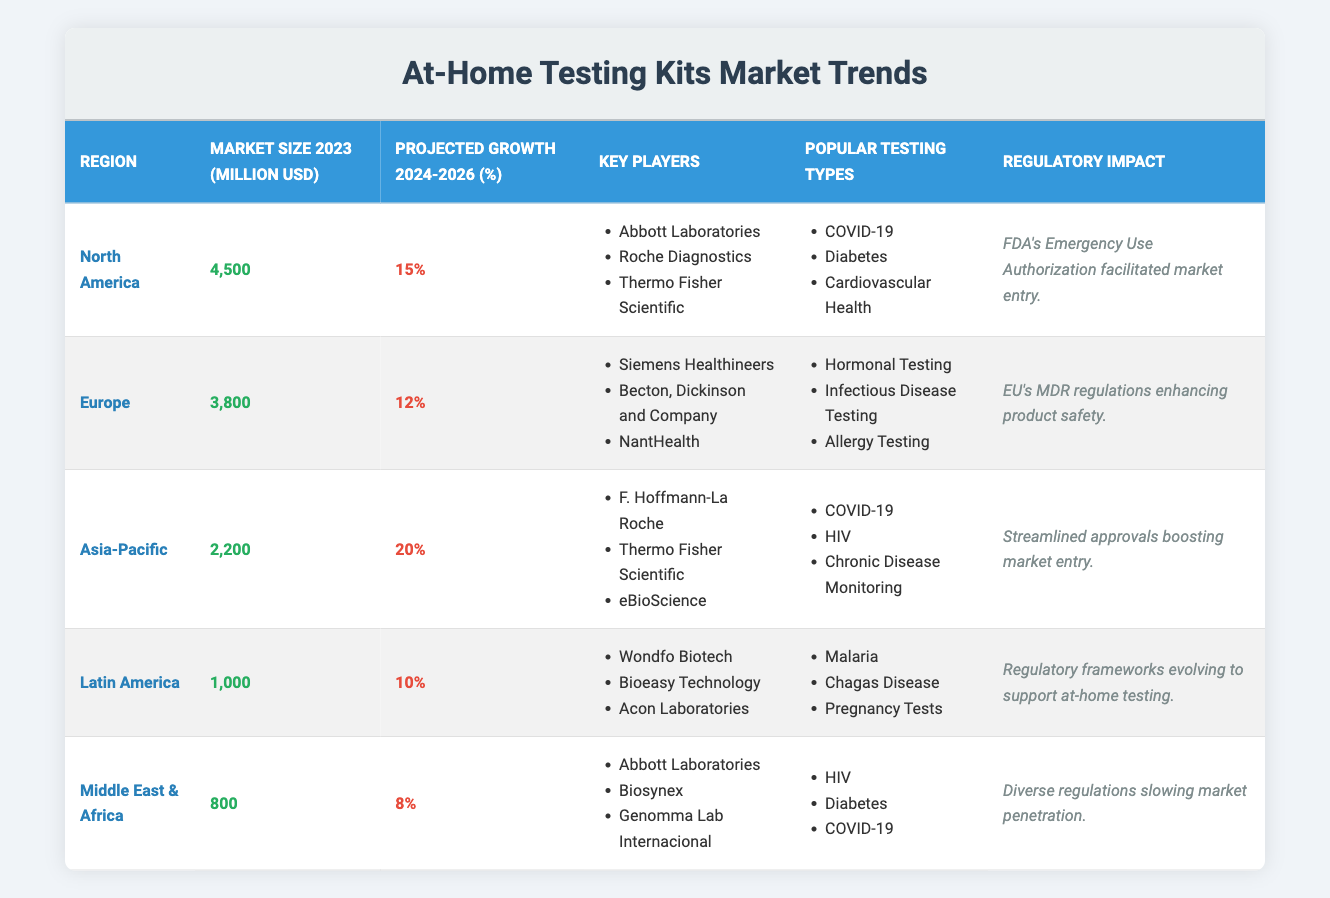What is the market size of at-home testing kits in Asia-Pacific in 2023? The table indicates that the market size for at-home testing kits in the Asia-Pacific region in 2023 is specified as 2,200 million USD.
Answer: 2,200 million USD Which region has the highest projected growth between 2024 and 2026? The projected growth rates for each region are listed as follows: North America (15%), Europe (12%), Asia-Pacific (20%), Latin America (10%), and Middle East & Africa (8%). The highest percentage is 20% for Asia-Pacific.
Answer: Asia-Pacific Are Roche Diagnostics one of the key players in the Latin America region? Checking the key players in Latin America, the list includes Wondfo Biotech, Bioeasy Technology, and Acon Laboratories, but not Roche Diagnostics. Therefore, the statement is false.
Answer: No What is the difference in market size between North America and Latin America in 2023? The market size for North America is 4,500 million USD, and for Latin America, it is 1,000 million USD. Subtracting these two values gives us 4,500 - 1,000 = 3,500 million USD as the difference.
Answer: 3,500 million USD Which region has the least projected growth and what is that percentage? Listing the projected growth percentages: North America (15%), Europe (12%), Asia-Pacific (20%), Latin America (10%), and Middle East & Africa (8%). The smallest value is 8% for the Middle East & Africa.
Answer: Middle East & Africa, 8% What are the popular testing types in Europe and how do they compare to those in North America? In Europe, the popular testing types are Hormonal Testing, Infectious Disease Testing, and Allergy Testing. In North America, they are COVID-19, Diabetes, and Cardiovascular Health. The comparison shows differing focuses based on regional health needs.
Answer: Different focuses How many million USD is the market size of the Middle East & Africa region compared to the Asia-Pacific region? The Middle East & Africa market size is 800 million USD, while Asia-Pacific is 2,200 million USD. Therefore, when comparing the two sizes, Asia-Pacific has 2,200 - 800 = 1,400 million USD more.
Answer: 1,400 million USD more True or False: All regions have projected growth percentages greater than 10%. Evaluating the growth percentages, we see North America (15%), Europe (12%), Asia-Pacific (20%), Latin America (10%), and Middle East & Africa (8%). Since the Middle East & Africa is 8%, the statement is false.
Answer: False What regulatory impact is noted for the European market in relation to at-home testing kits? The regulatory impact specified for Europe indicates that the EU's MDR regulations are enhancing product safety, thus facilitating a reliable market for at-home testing kits.
Answer: EU's MDR regulations enhancing product safety Which regions have "COVID-19" as one of their popular testing types? Reviewing the popular testing types by region, COVID-19 appears in North America, Asia-Pacific, and the Middle East & Africa.
Answer: North America, Asia-Pacific, Middle East & Africa 